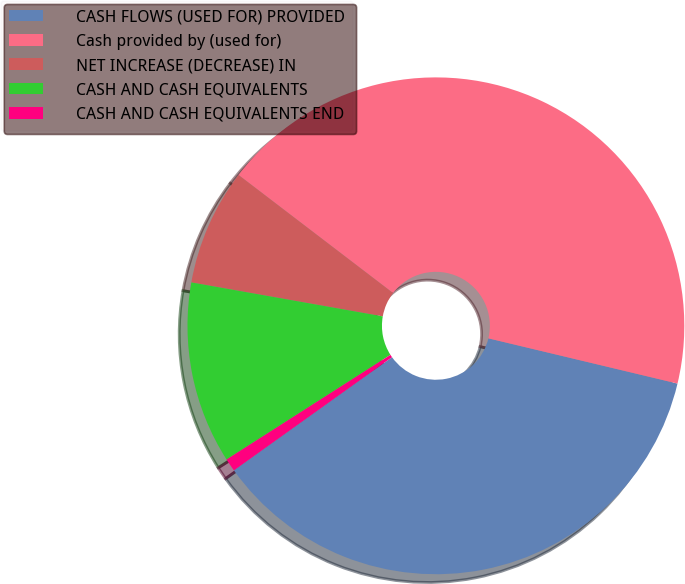<chart> <loc_0><loc_0><loc_500><loc_500><pie_chart><fcel>CASH FLOWS (USED FOR) PROVIDED<fcel>Cash provided by (used for)<fcel>NET INCREASE (DECREASE) IN<fcel>CASH AND CASH EQUIVALENTS<fcel>CASH AND CASH EQUIVALENTS END<nl><fcel>36.38%<fcel>43.35%<fcel>7.59%<fcel>11.84%<fcel>0.84%<nl></chart> 